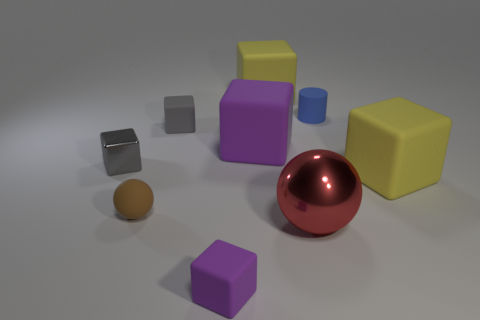Subtract all yellow blocks. How many blocks are left? 4 Subtract 2 cubes. How many cubes are left? 4 Subtract all yellow rubber cubes. How many cubes are left? 4 Subtract all yellow cubes. Subtract all brown cylinders. How many cubes are left? 4 Add 1 yellow metallic spheres. How many objects exist? 10 Subtract all balls. How many objects are left? 7 Add 4 small blue objects. How many small blue objects exist? 5 Subtract 0 cyan cubes. How many objects are left? 9 Subtract all spheres. Subtract all red rubber cylinders. How many objects are left? 7 Add 6 big blocks. How many big blocks are left? 9 